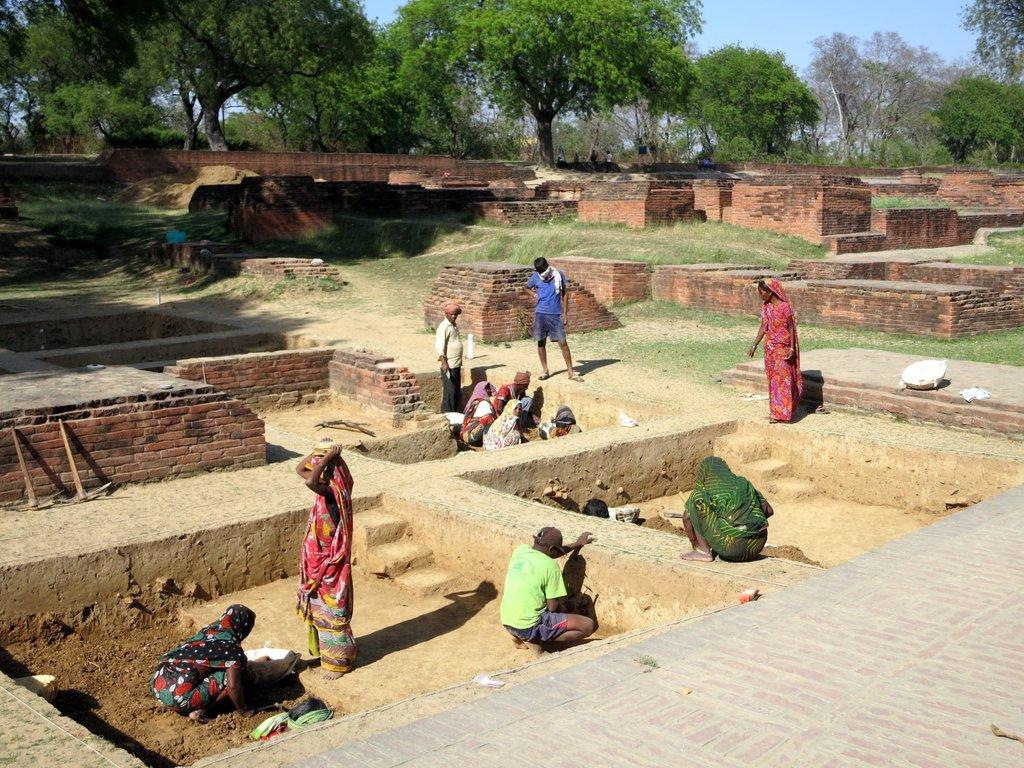What are the people in the image doing? The people in the image are standing and sitting. What type of material is used to construct the structure in the image? There are red bricks arranged in the image. What objects are present in the image that resemble a specific tool? There are two axes in the image. What type of natural environment can be seen in the background of the image? There are trees in the background of the image. What is visible in the sky in the background of the image? The sky is visible in the background of the image. How many legs does the grandmother have in the image? There is no grandmother present in the image, so it is not possible to determine the number of legs she might have. 